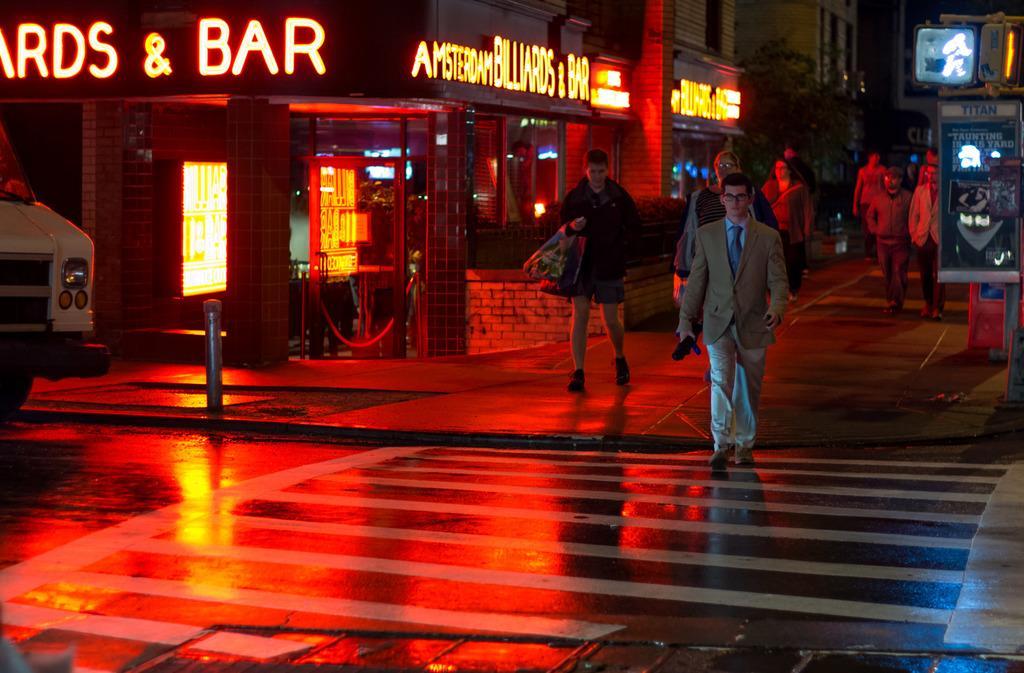Can you describe this image briefly? These are buildings with windows. Here we can see three, people and vehicles is on the road. These is banner. 